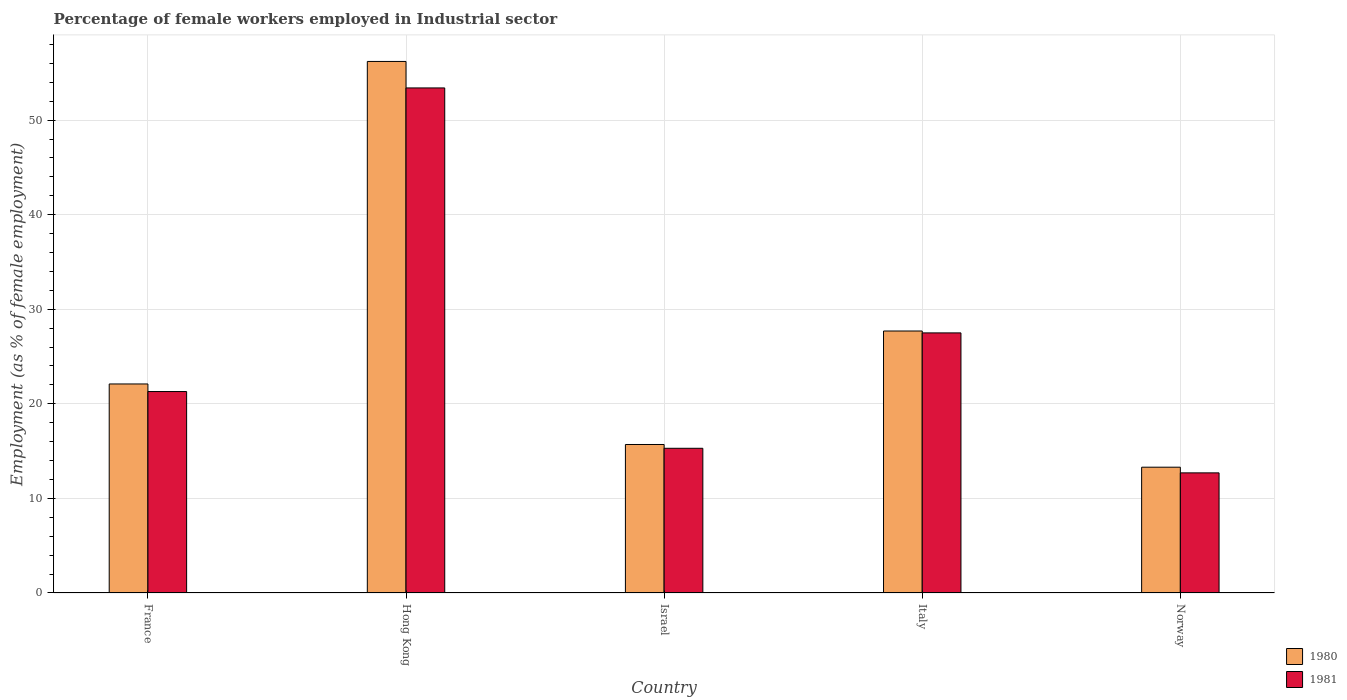How many different coloured bars are there?
Your answer should be very brief. 2. How many groups of bars are there?
Keep it short and to the point. 5. Are the number of bars on each tick of the X-axis equal?
Give a very brief answer. Yes. What is the label of the 1st group of bars from the left?
Ensure brevity in your answer.  France. What is the percentage of females employed in Industrial sector in 1980 in Norway?
Make the answer very short. 13.3. Across all countries, what is the maximum percentage of females employed in Industrial sector in 1981?
Provide a short and direct response. 53.4. Across all countries, what is the minimum percentage of females employed in Industrial sector in 1981?
Offer a terse response. 12.7. In which country was the percentage of females employed in Industrial sector in 1981 maximum?
Offer a very short reply. Hong Kong. In which country was the percentage of females employed in Industrial sector in 1981 minimum?
Your response must be concise. Norway. What is the total percentage of females employed in Industrial sector in 1980 in the graph?
Provide a short and direct response. 135. What is the difference between the percentage of females employed in Industrial sector in 1981 in Hong Kong and that in Norway?
Keep it short and to the point. 40.7. What is the difference between the percentage of females employed in Industrial sector in 1980 in Norway and the percentage of females employed in Industrial sector in 1981 in Italy?
Your answer should be compact. -14.2. What is the average percentage of females employed in Industrial sector in 1981 per country?
Keep it short and to the point. 26.04. What is the difference between the percentage of females employed in Industrial sector of/in 1980 and percentage of females employed in Industrial sector of/in 1981 in Norway?
Your answer should be very brief. 0.6. In how many countries, is the percentage of females employed in Industrial sector in 1981 greater than 28 %?
Offer a terse response. 1. What is the ratio of the percentage of females employed in Industrial sector in 1980 in Israel to that in Italy?
Keep it short and to the point. 0.57. Is the percentage of females employed in Industrial sector in 1981 in Hong Kong less than that in Italy?
Offer a terse response. No. Is the difference between the percentage of females employed in Industrial sector in 1980 in Italy and Norway greater than the difference between the percentage of females employed in Industrial sector in 1981 in Italy and Norway?
Ensure brevity in your answer.  No. What is the difference between the highest and the second highest percentage of females employed in Industrial sector in 1980?
Ensure brevity in your answer.  28.5. What is the difference between the highest and the lowest percentage of females employed in Industrial sector in 1980?
Provide a short and direct response. 42.9. In how many countries, is the percentage of females employed in Industrial sector in 1981 greater than the average percentage of females employed in Industrial sector in 1981 taken over all countries?
Your answer should be compact. 2. Is the sum of the percentage of females employed in Industrial sector in 1980 in Israel and Italy greater than the maximum percentage of females employed in Industrial sector in 1981 across all countries?
Make the answer very short. No. How many bars are there?
Your answer should be compact. 10. What is the difference between two consecutive major ticks on the Y-axis?
Your response must be concise. 10. How are the legend labels stacked?
Give a very brief answer. Vertical. What is the title of the graph?
Your answer should be compact. Percentage of female workers employed in Industrial sector. What is the label or title of the Y-axis?
Ensure brevity in your answer.  Employment (as % of female employment). What is the Employment (as % of female employment) of 1980 in France?
Give a very brief answer. 22.1. What is the Employment (as % of female employment) in 1981 in France?
Ensure brevity in your answer.  21.3. What is the Employment (as % of female employment) of 1980 in Hong Kong?
Give a very brief answer. 56.2. What is the Employment (as % of female employment) of 1981 in Hong Kong?
Ensure brevity in your answer.  53.4. What is the Employment (as % of female employment) in 1980 in Israel?
Keep it short and to the point. 15.7. What is the Employment (as % of female employment) in 1981 in Israel?
Your response must be concise. 15.3. What is the Employment (as % of female employment) of 1980 in Italy?
Your response must be concise. 27.7. What is the Employment (as % of female employment) of 1981 in Italy?
Ensure brevity in your answer.  27.5. What is the Employment (as % of female employment) in 1980 in Norway?
Your response must be concise. 13.3. What is the Employment (as % of female employment) in 1981 in Norway?
Offer a very short reply. 12.7. Across all countries, what is the maximum Employment (as % of female employment) of 1980?
Provide a succinct answer. 56.2. Across all countries, what is the maximum Employment (as % of female employment) of 1981?
Give a very brief answer. 53.4. Across all countries, what is the minimum Employment (as % of female employment) in 1980?
Make the answer very short. 13.3. Across all countries, what is the minimum Employment (as % of female employment) in 1981?
Make the answer very short. 12.7. What is the total Employment (as % of female employment) in 1980 in the graph?
Make the answer very short. 135. What is the total Employment (as % of female employment) in 1981 in the graph?
Provide a short and direct response. 130.2. What is the difference between the Employment (as % of female employment) in 1980 in France and that in Hong Kong?
Keep it short and to the point. -34.1. What is the difference between the Employment (as % of female employment) of 1981 in France and that in Hong Kong?
Make the answer very short. -32.1. What is the difference between the Employment (as % of female employment) in 1981 in France and that in Israel?
Your answer should be compact. 6. What is the difference between the Employment (as % of female employment) of 1980 in France and that in Italy?
Offer a terse response. -5.6. What is the difference between the Employment (as % of female employment) of 1981 in France and that in Italy?
Your answer should be very brief. -6.2. What is the difference between the Employment (as % of female employment) of 1980 in France and that in Norway?
Your answer should be very brief. 8.8. What is the difference between the Employment (as % of female employment) in 1980 in Hong Kong and that in Israel?
Offer a very short reply. 40.5. What is the difference between the Employment (as % of female employment) in 1981 in Hong Kong and that in Israel?
Keep it short and to the point. 38.1. What is the difference between the Employment (as % of female employment) in 1980 in Hong Kong and that in Italy?
Your response must be concise. 28.5. What is the difference between the Employment (as % of female employment) of 1981 in Hong Kong and that in Italy?
Give a very brief answer. 25.9. What is the difference between the Employment (as % of female employment) of 1980 in Hong Kong and that in Norway?
Give a very brief answer. 42.9. What is the difference between the Employment (as % of female employment) in 1981 in Hong Kong and that in Norway?
Ensure brevity in your answer.  40.7. What is the difference between the Employment (as % of female employment) in 1980 in Israel and that in Italy?
Your answer should be compact. -12. What is the difference between the Employment (as % of female employment) of 1981 in Israel and that in Italy?
Offer a very short reply. -12.2. What is the difference between the Employment (as % of female employment) of 1980 in Israel and that in Norway?
Your answer should be very brief. 2.4. What is the difference between the Employment (as % of female employment) of 1981 in Israel and that in Norway?
Provide a succinct answer. 2.6. What is the difference between the Employment (as % of female employment) in 1981 in Italy and that in Norway?
Provide a short and direct response. 14.8. What is the difference between the Employment (as % of female employment) in 1980 in France and the Employment (as % of female employment) in 1981 in Hong Kong?
Offer a very short reply. -31.3. What is the difference between the Employment (as % of female employment) in 1980 in France and the Employment (as % of female employment) in 1981 in Israel?
Your response must be concise. 6.8. What is the difference between the Employment (as % of female employment) of 1980 in Hong Kong and the Employment (as % of female employment) of 1981 in Israel?
Offer a terse response. 40.9. What is the difference between the Employment (as % of female employment) of 1980 in Hong Kong and the Employment (as % of female employment) of 1981 in Italy?
Ensure brevity in your answer.  28.7. What is the difference between the Employment (as % of female employment) in 1980 in Hong Kong and the Employment (as % of female employment) in 1981 in Norway?
Give a very brief answer. 43.5. What is the average Employment (as % of female employment) in 1981 per country?
Give a very brief answer. 26.04. What is the difference between the Employment (as % of female employment) of 1980 and Employment (as % of female employment) of 1981 in France?
Provide a succinct answer. 0.8. What is the difference between the Employment (as % of female employment) in 1980 and Employment (as % of female employment) in 1981 in Italy?
Ensure brevity in your answer.  0.2. What is the ratio of the Employment (as % of female employment) of 1980 in France to that in Hong Kong?
Give a very brief answer. 0.39. What is the ratio of the Employment (as % of female employment) in 1981 in France to that in Hong Kong?
Your response must be concise. 0.4. What is the ratio of the Employment (as % of female employment) of 1980 in France to that in Israel?
Ensure brevity in your answer.  1.41. What is the ratio of the Employment (as % of female employment) of 1981 in France to that in Israel?
Your answer should be compact. 1.39. What is the ratio of the Employment (as % of female employment) of 1980 in France to that in Italy?
Provide a succinct answer. 0.8. What is the ratio of the Employment (as % of female employment) of 1981 in France to that in Italy?
Keep it short and to the point. 0.77. What is the ratio of the Employment (as % of female employment) in 1980 in France to that in Norway?
Your answer should be very brief. 1.66. What is the ratio of the Employment (as % of female employment) of 1981 in France to that in Norway?
Provide a succinct answer. 1.68. What is the ratio of the Employment (as % of female employment) in 1980 in Hong Kong to that in Israel?
Ensure brevity in your answer.  3.58. What is the ratio of the Employment (as % of female employment) of 1981 in Hong Kong to that in Israel?
Your answer should be compact. 3.49. What is the ratio of the Employment (as % of female employment) in 1980 in Hong Kong to that in Italy?
Your response must be concise. 2.03. What is the ratio of the Employment (as % of female employment) of 1981 in Hong Kong to that in Italy?
Provide a succinct answer. 1.94. What is the ratio of the Employment (as % of female employment) in 1980 in Hong Kong to that in Norway?
Ensure brevity in your answer.  4.23. What is the ratio of the Employment (as % of female employment) in 1981 in Hong Kong to that in Norway?
Your response must be concise. 4.2. What is the ratio of the Employment (as % of female employment) of 1980 in Israel to that in Italy?
Give a very brief answer. 0.57. What is the ratio of the Employment (as % of female employment) of 1981 in Israel to that in Italy?
Your response must be concise. 0.56. What is the ratio of the Employment (as % of female employment) of 1980 in Israel to that in Norway?
Provide a succinct answer. 1.18. What is the ratio of the Employment (as % of female employment) in 1981 in Israel to that in Norway?
Keep it short and to the point. 1.2. What is the ratio of the Employment (as % of female employment) in 1980 in Italy to that in Norway?
Provide a succinct answer. 2.08. What is the ratio of the Employment (as % of female employment) of 1981 in Italy to that in Norway?
Ensure brevity in your answer.  2.17. What is the difference between the highest and the second highest Employment (as % of female employment) in 1980?
Ensure brevity in your answer.  28.5. What is the difference between the highest and the second highest Employment (as % of female employment) in 1981?
Make the answer very short. 25.9. What is the difference between the highest and the lowest Employment (as % of female employment) of 1980?
Offer a terse response. 42.9. What is the difference between the highest and the lowest Employment (as % of female employment) in 1981?
Keep it short and to the point. 40.7. 